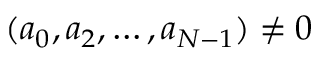<formula> <loc_0><loc_0><loc_500><loc_500>( a _ { 0 } , a _ { 2 } , \dots , a _ { N - 1 } ) \neq 0</formula> 